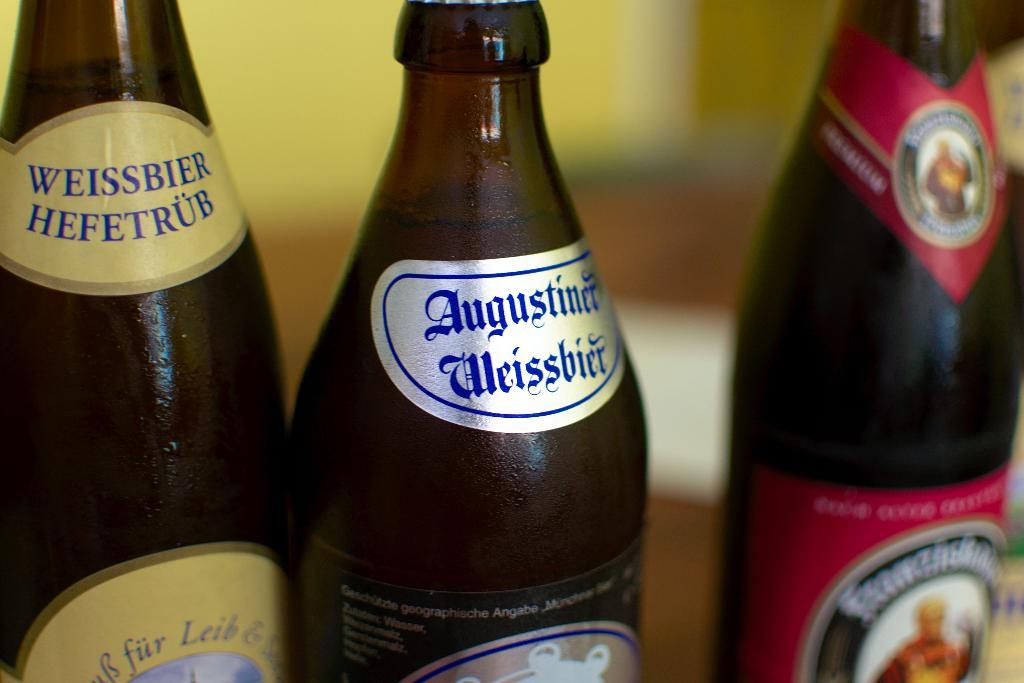Provide a one-sentence caption for the provided image. three bottles of beer in a row with the middle being augustiner. 